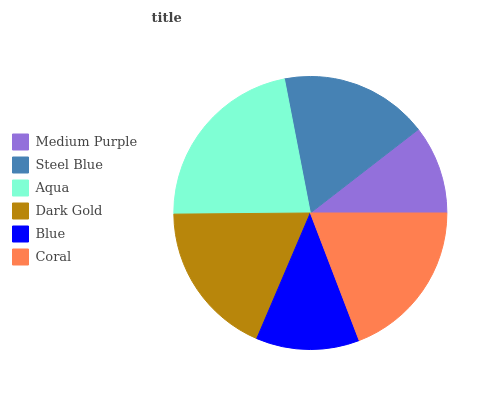Is Medium Purple the minimum?
Answer yes or no. Yes. Is Aqua the maximum?
Answer yes or no. Yes. Is Steel Blue the minimum?
Answer yes or no. No. Is Steel Blue the maximum?
Answer yes or no. No. Is Steel Blue greater than Medium Purple?
Answer yes or no. Yes. Is Medium Purple less than Steel Blue?
Answer yes or no. Yes. Is Medium Purple greater than Steel Blue?
Answer yes or no. No. Is Steel Blue less than Medium Purple?
Answer yes or no. No. Is Dark Gold the high median?
Answer yes or no. Yes. Is Steel Blue the low median?
Answer yes or no. Yes. Is Aqua the high median?
Answer yes or no. No. Is Aqua the low median?
Answer yes or no. No. 